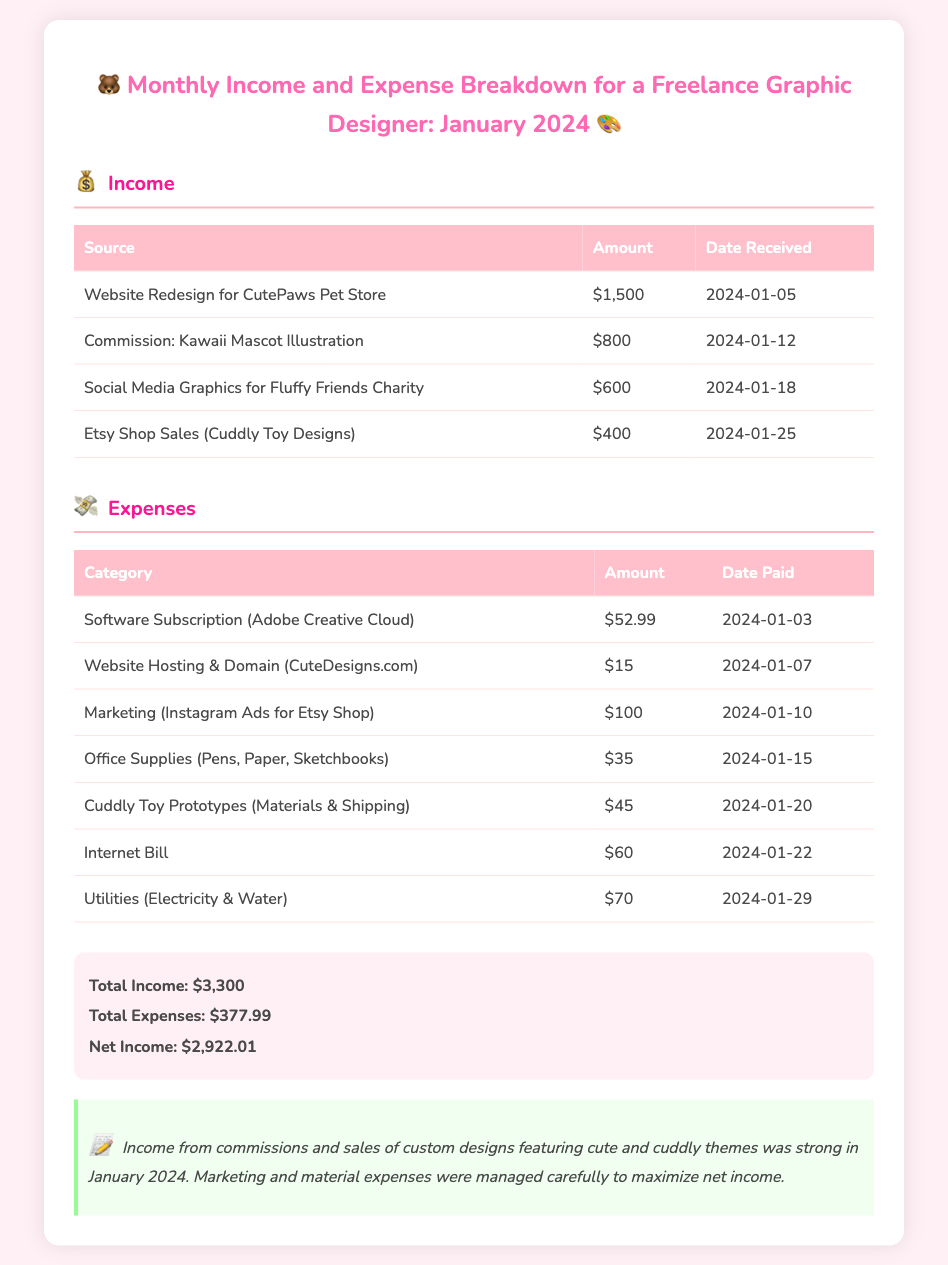What is the total income? The total income is the sum of all income sources listed in the document, which is $1,500 + $800 + $600 + $400 = $3,300.
Answer: $3,300 What is the total expense? The total expense is the sum of all expenses listed in the document, which is $52.99 + $15 + $100 + $35 + $45 + $60 + $70 = $377.99.
Answer: $377.99 What was the date received for the website redesign? The date received for the website redesign is specified in the document as January 5, 2024.
Answer: January 5, 2024 How much was earned from Etsy Shop Sales? The amount earned from Etsy Shop Sales is listed in the income section of the document as $400.
Answer: $400 What was the largest expense category? The largest expense category in the document is the Internet Bill, which amounts to $60.
Answer: Internet Bill What is the net income for January 2024? The net income is calculated by subtracting total expenses from total income, which is $3,300 - $377.99 = $2,922.01.
Answer: $2,922.01 When were the cuddly toy prototypes paid for? The payment for cuddly toy prototypes was made on January 20, 2024, as stated in the expense section.
Answer: January 20, 2024 What type of projects are highlighted in the income section? The income section highlights projects related to cute and cuddly themes, including pet store redesign and mascot illustration.
Answer: Cute and cuddly themes What design software subscription is mentioned as an expense? The document mentions Adobe Creative Cloud as the software subscription expense.
Answer: Adobe Creative Cloud 